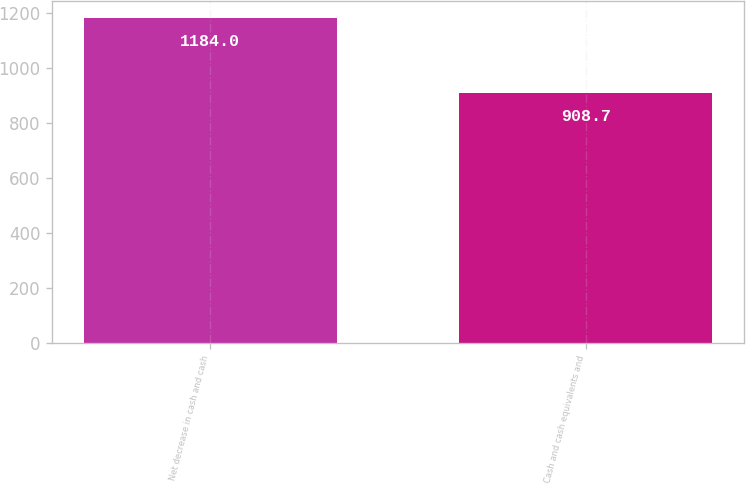<chart> <loc_0><loc_0><loc_500><loc_500><bar_chart><fcel>Net decrease in cash and cash<fcel>Cash and cash equivalents and<nl><fcel>1184<fcel>908.7<nl></chart> 